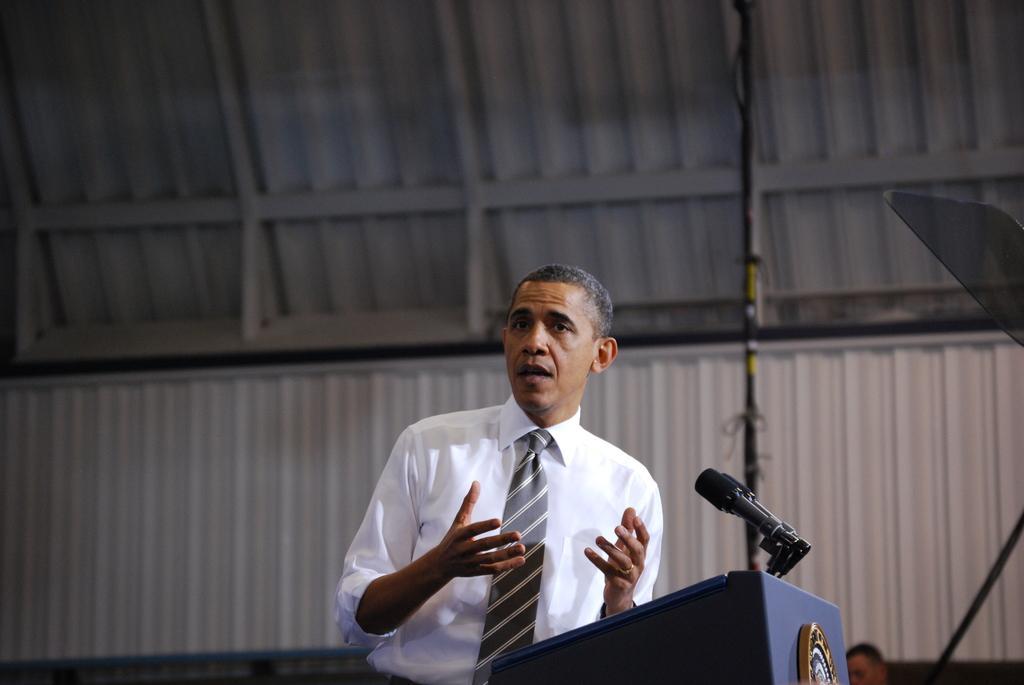Could you give a brief overview of what you see in this image? In the image we can see a man standing, wearing clothes, finger ring and it looks like he is talking. Here we can see podium, microphones and the background is slightly blurred. 